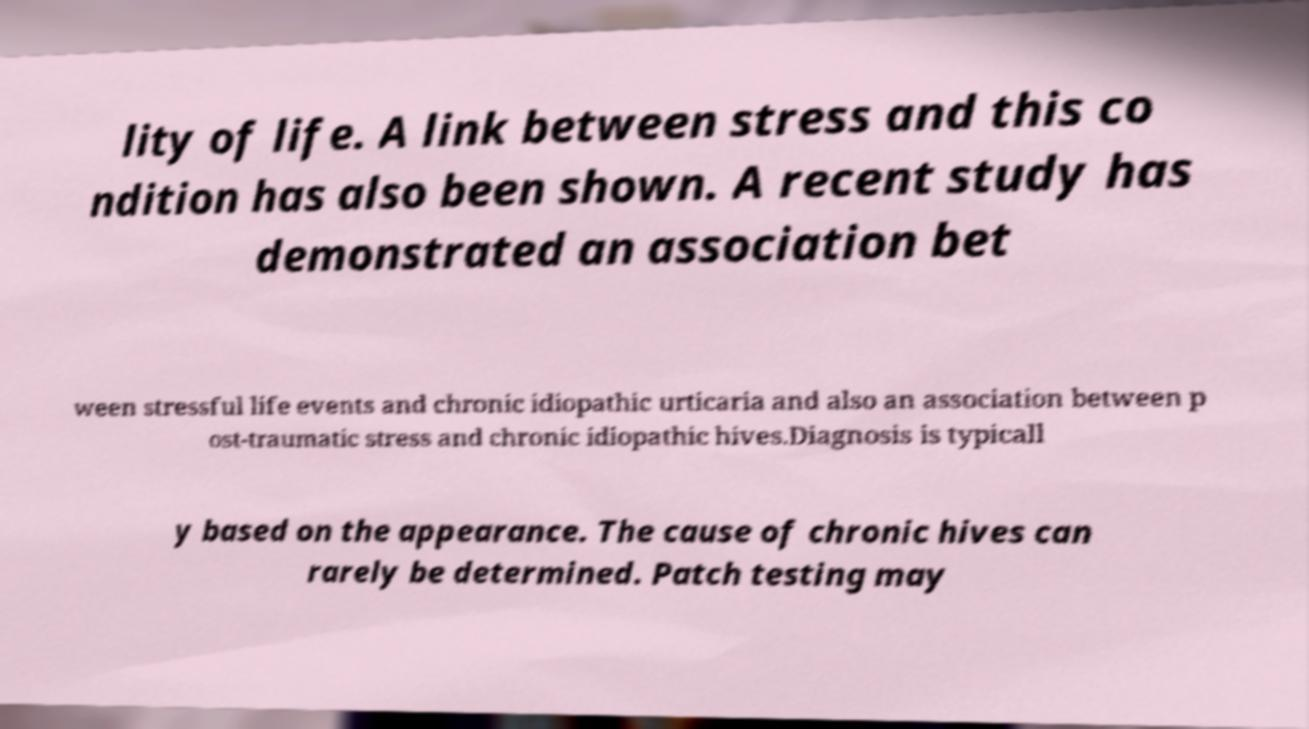For documentation purposes, I need the text within this image transcribed. Could you provide that? lity of life. A link between stress and this co ndition has also been shown. A recent study has demonstrated an association bet ween stressful life events and chronic idiopathic urticaria and also an association between p ost-traumatic stress and chronic idiopathic hives.Diagnosis is typicall y based on the appearance. The cause of chronic hives can rarely be determined. Patch testing may 